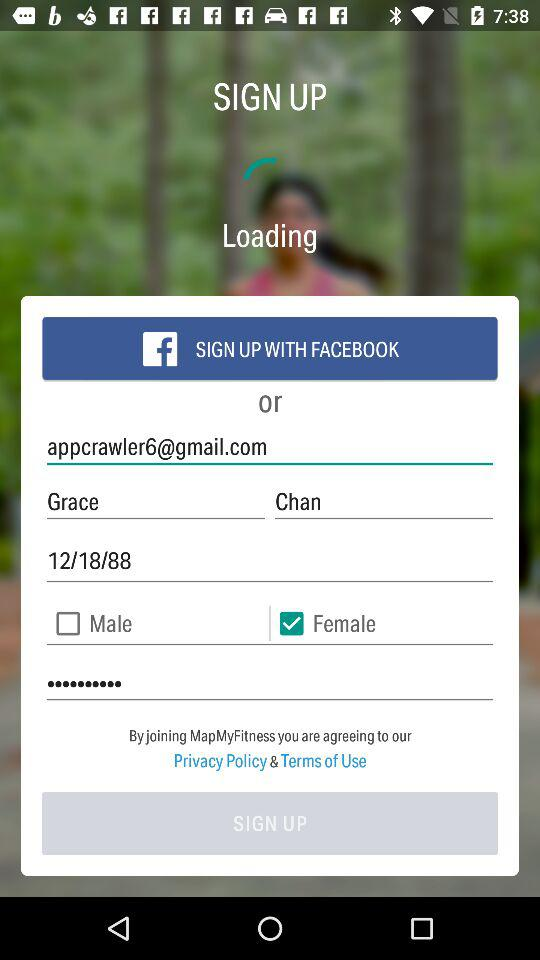What is the name of the person? The name of the person is Grace Chan. 